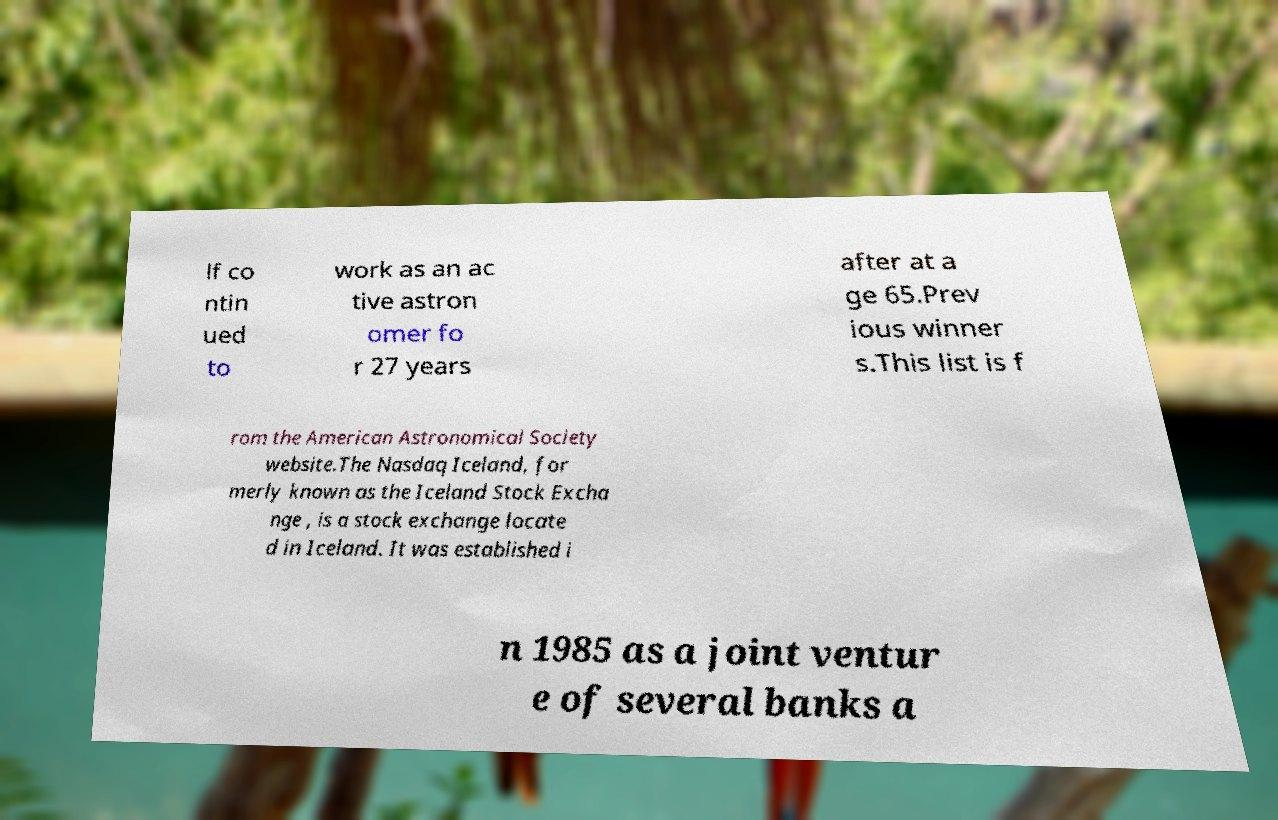For documentation purposes, I need the text within this image transcribed. Could you provide that? lf co ntin ued to work as an ac tive astron omer fo r 27 years after at a ge 65.Prev ious winner s.This list is f rom the American Astronomical Society website.The Nasdaq Iceland, for merly known as the Iceland Stock Excha nge , is a stock exchange locate d in Iceland. It was established i n 1985 as a joint ventur e of several banks a 